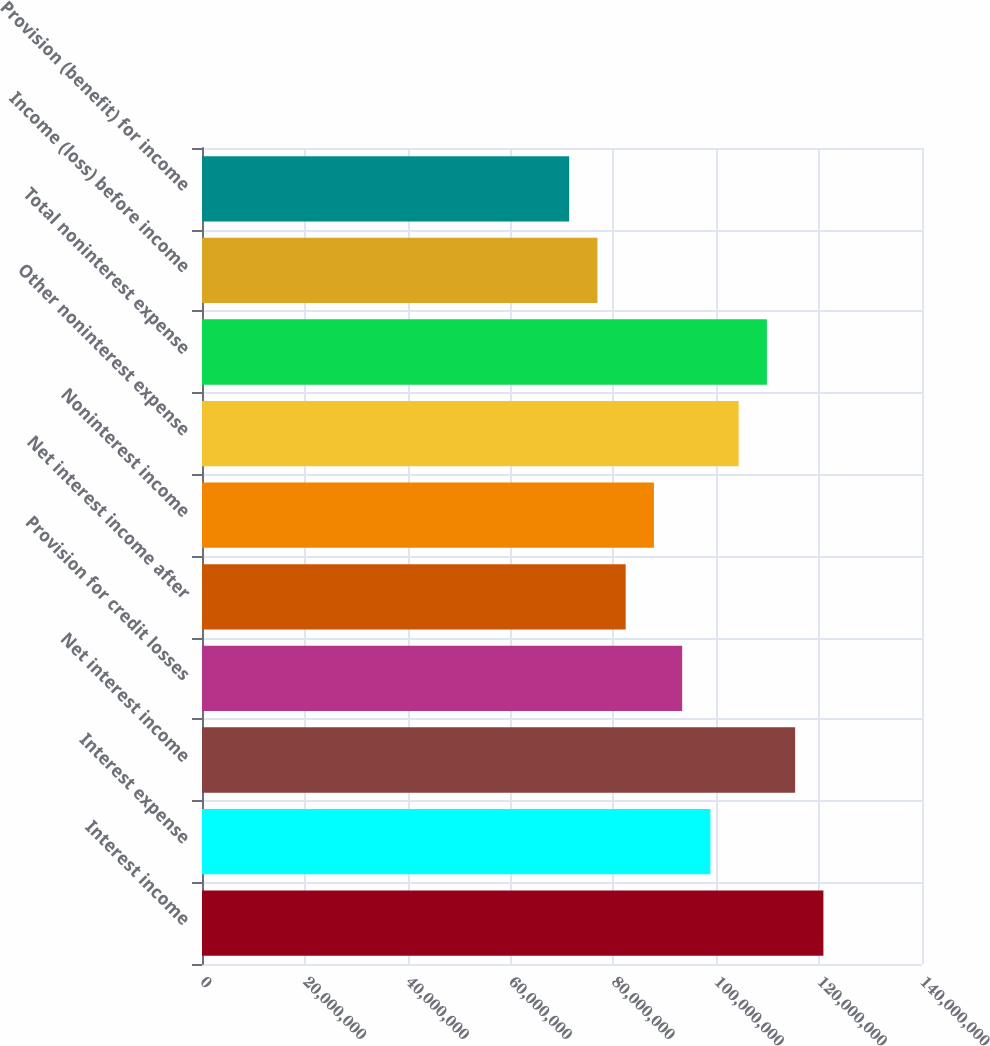Convert chart. <chart><loc_0><loc_0><loc_500><loc_500><bar_chart><fcel>Interest income<fcel>Interest expense<fcel>Net interest income<fcel>Provision for credit losses<fcel>Net interest income after<fcel>Noninterest income<fcel>Other noninterest expense<fcel>Total noninterest expense<fcel>Income (loss) before income<fcel>Provision (benefit) for income<nl><fcel>1.20827e+08<fcel>9.88586e+07<fcel>1.15335e+08<fcel>9.33664e+07<fcel>8.23821e+07<fcel>8.78743e+07<fcel>1.04351e+08<fcel>1.09843e+08<fcel>7.689e+07<fcel>7.13978e+07<nl></chart> 